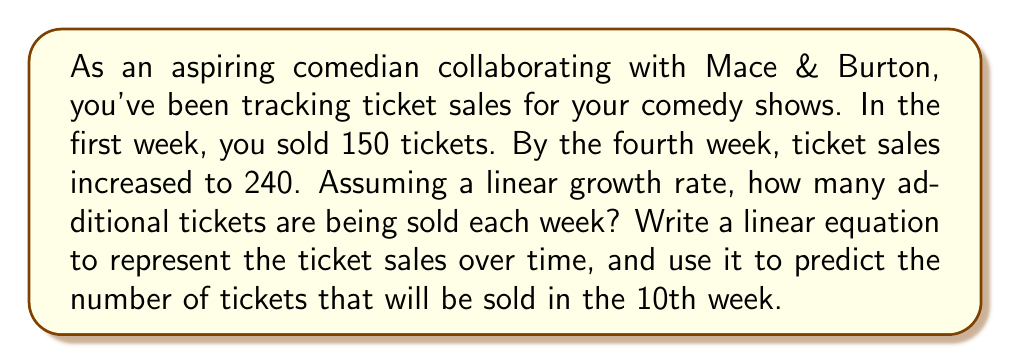Can you answer this question? Let's approach this step-by-step:

1) First, we need to find the rate of increase per week. We can use the point-slope form of a linear equation:

   $y - y_1 = m(x - x_1)$

   Where $m$ is the slope (rate of increase), $(x_1, y_1)$ is the initial point, and $(x, y)$ is any point on the line.

2) We have two points:
   Week 1: (1, 150)
   Week 4: (4, 240)

3) We can calculate the slope:

   $m = \frac{y_2 - y_1}{x_2 - x_1} = \frac{240 - 150}{4 - 1} = \frac{90}{3} = 30$

   This means 30 additional tickets are being sold each week.

4) Now we can write the linear equation. Using the point-slope form with the first point (1, 150):

   $y - 150 = 30(x - 1)$

5) Simplify to slope-intercept form:

   $y = 30x - 30 + 150$
   $y = 30x + 120$

   Where $y$ is the number of tickets sold and $x$ is the week number.

6) To predict the number of tickets sold in the 10th week, we substitute $x = 10$:

   $y = 30(10) + 120 = 300 + 120 = 420$

Therefore, 420 tickets are predicted to be sold in the 10th week.
Answer: The rate of ticket sales increase is 30 tickets per week. The linear equation representing ticket sales over time is $y = 30x + 120$, where $y$ is the number of tickets sold and $x$ is the week number. In the 10th week, 420 tickets are predicted to be sold. 